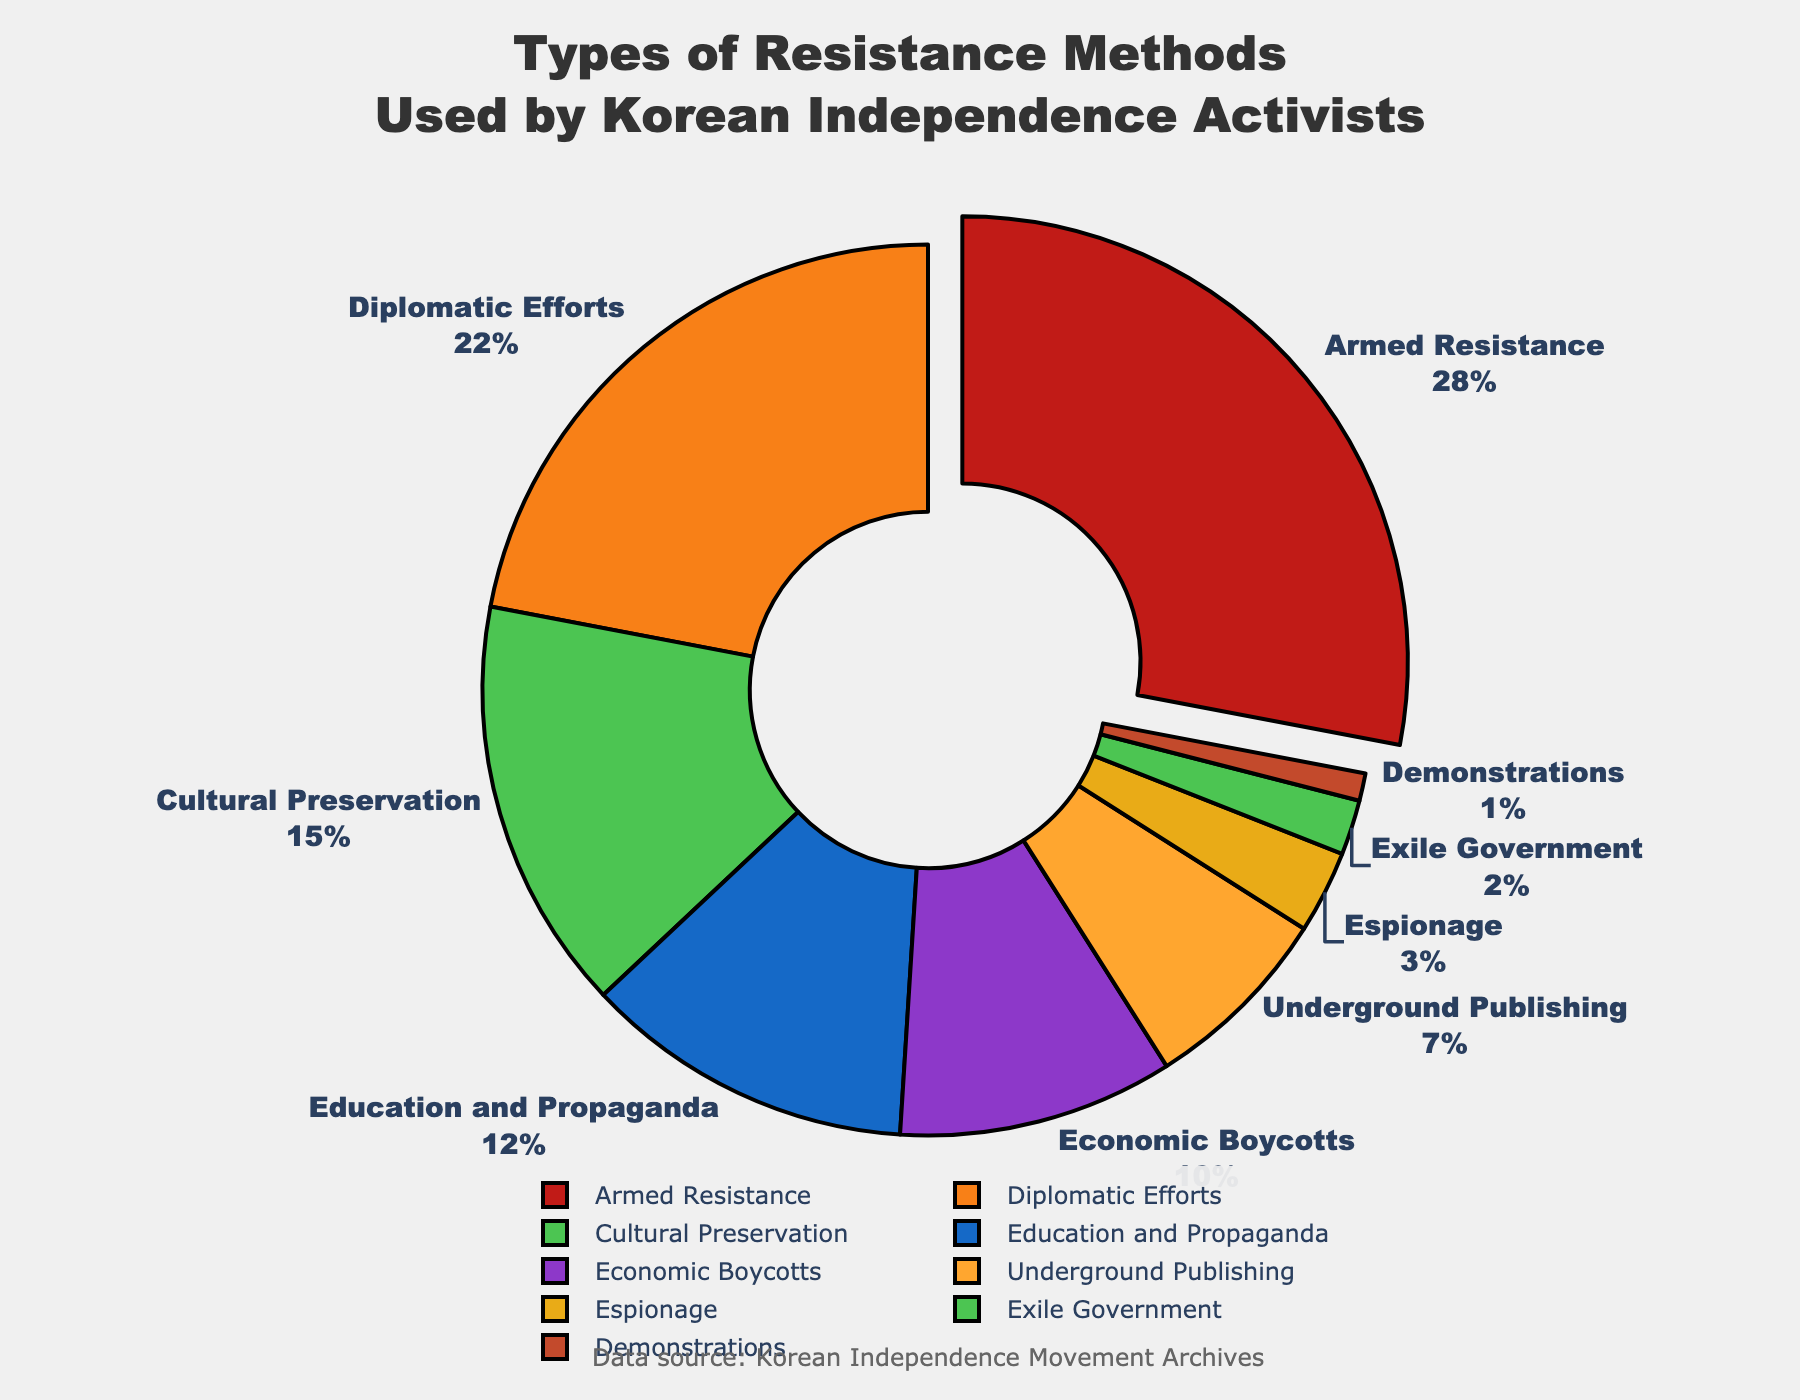What's the most common method of resistance among Korean independence activists? The pie chart shows the largest percentage segment is "Armed Resistance" with 28%.
Answer: Armed Resistance Which two methods together account for the highest combined percentage? The two largest segments are "Armed Resistance" (28%) and "Diplomatic Efforts" (22%). Their combined percentage is 28% + 22% = 50%.
Answer: Armed Resistance and Diplomatic Efforts How many resistance methods have percentages below 5%? The methods with percentages below 5% are "Exile Government" (2%) and "Demonstrations" (1%). There are 2 such methods.
Answer: 2 By how much does the percentage of "Armed Resistance" exceed that of "Education and Propaganda"? The percentage for "Armed Resistance" is 28% and for "Education and Propaganda" is 12%. The difference is 28% - 12% = 16%.
Answer: 16% What colors represent "Diplomatic Efforts" and "Cultural Preservation"? The pie chart colors show "Diplomatic Efforts" is represented in orange (#F88017) and "Cultural Preservation" in green (#4CC552).
Answer: Orange and Green Which resistance method has the smallest percentage, and what is its exact percentage? The smallest segment is "Demonstrations" with a percentage of 1%.
Answer: Demonstrations, 1% How does the percentage of "Economic Boycotts" compare to "Underground Publishing"? The percentage for "Economic Boycotts" is 10% and for "Underground Publishing" is 7%. Therefore, "Economic Boycotts" is greater.
Answer: Economic Boycotts is greater If you sum the percentages of all methods excluding "Armed Resistance", what is the total? All other methods combined percentages are Diplomatic Efforts (22%), Cultural Preservation (15%), Education and Propaganda (12%), Economic Boycotts (10%), Underground Publishing (7%), Espionage (3%), Exile Government (2%), and Demonstrations (1%). Summing them up: 22 + 15 + 12 + 10 + 7 + 3 + 2 + 1 = 72%.
Answer: 72% What is the difference in terms of percentage points between "Cultural Preservation" and "Economic Boycotts"? The percentage for "Cultural Preservation" is 15% and for "Economic Boycotts" is 10%. The difference is 15% - 10% = 5%.
Answer: 5% How many methods have a percentage of 10% or higher? The methods with percentages 10% or higher are "Armed Resistance" (28%), "Diplomatic Efforts" (22%), "Cultural Preservation" (15%), "Education and Propaganda" (12%), and "Economic Boycotts" (10%). There are 5 such methods.
Answer: 5 